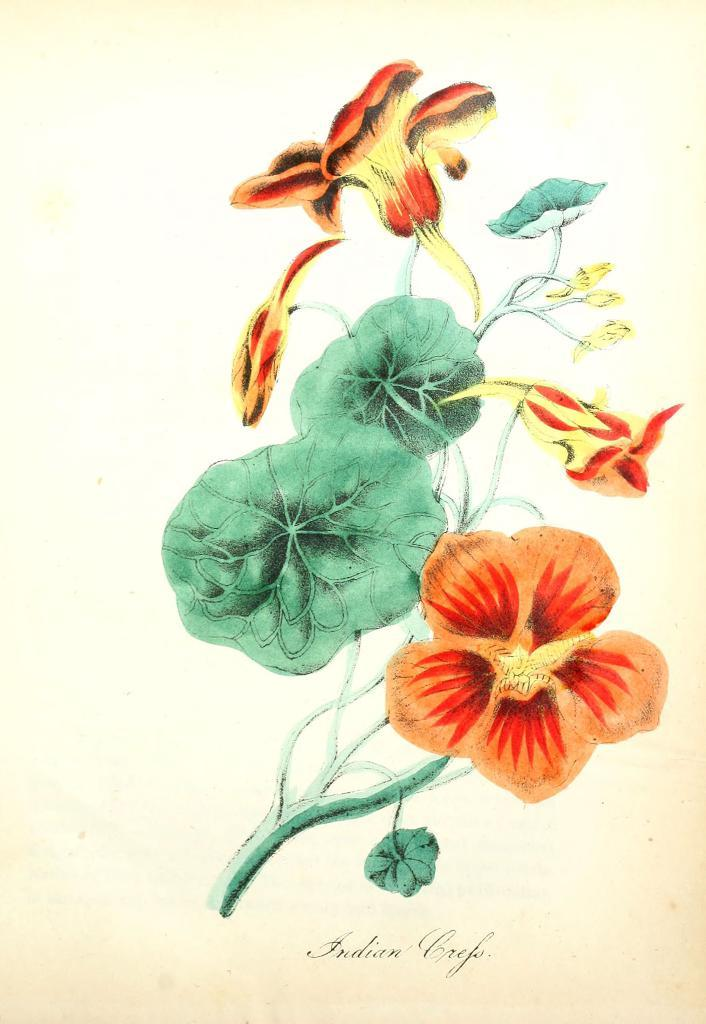What is the main subject of the painting in the image? The painting depicts flowers. What colors are the flowers in the painting? The flowers are orange and yellow in color. What is the color of the plant associated with the flowers? The plant is green in color. What is the background color of the painting? The painting has a cream-colored background. How many members are on the committee depicted in the painting? There is no committee depicted in the painting; it features flowers and a plant. Can you describe the type of skate used by the flowers in the painting? There are no skates present in the painting; it features flowers and a plant. 